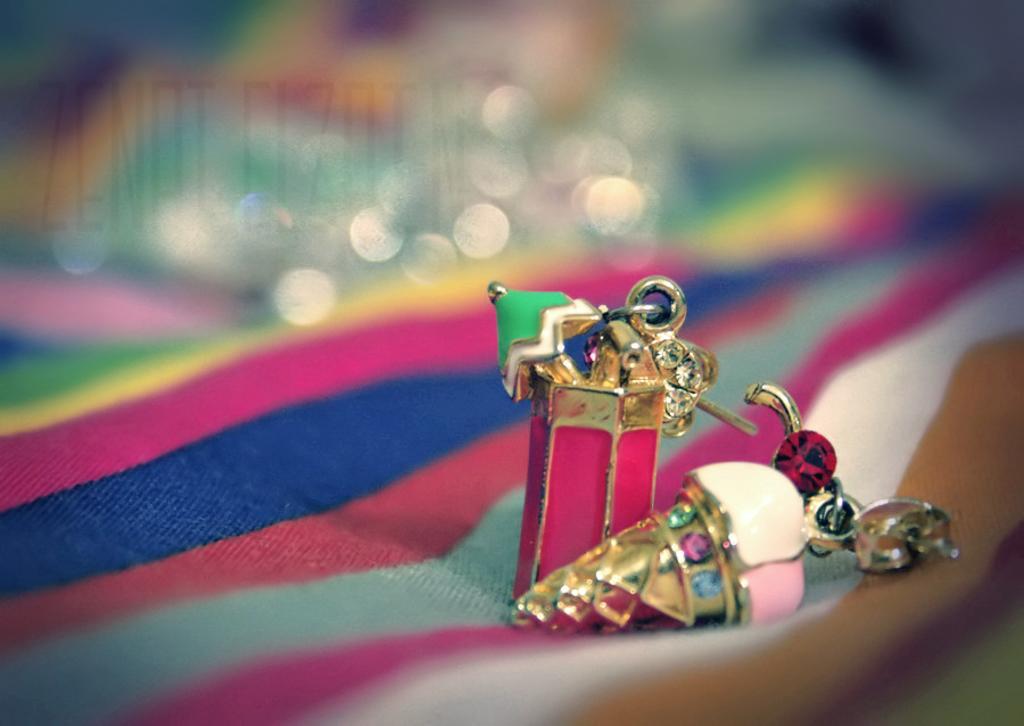In one or two sentences, can you explain what this image depicts? In this image I can see few objects on the colorful cloth. And there is a blurred background. 